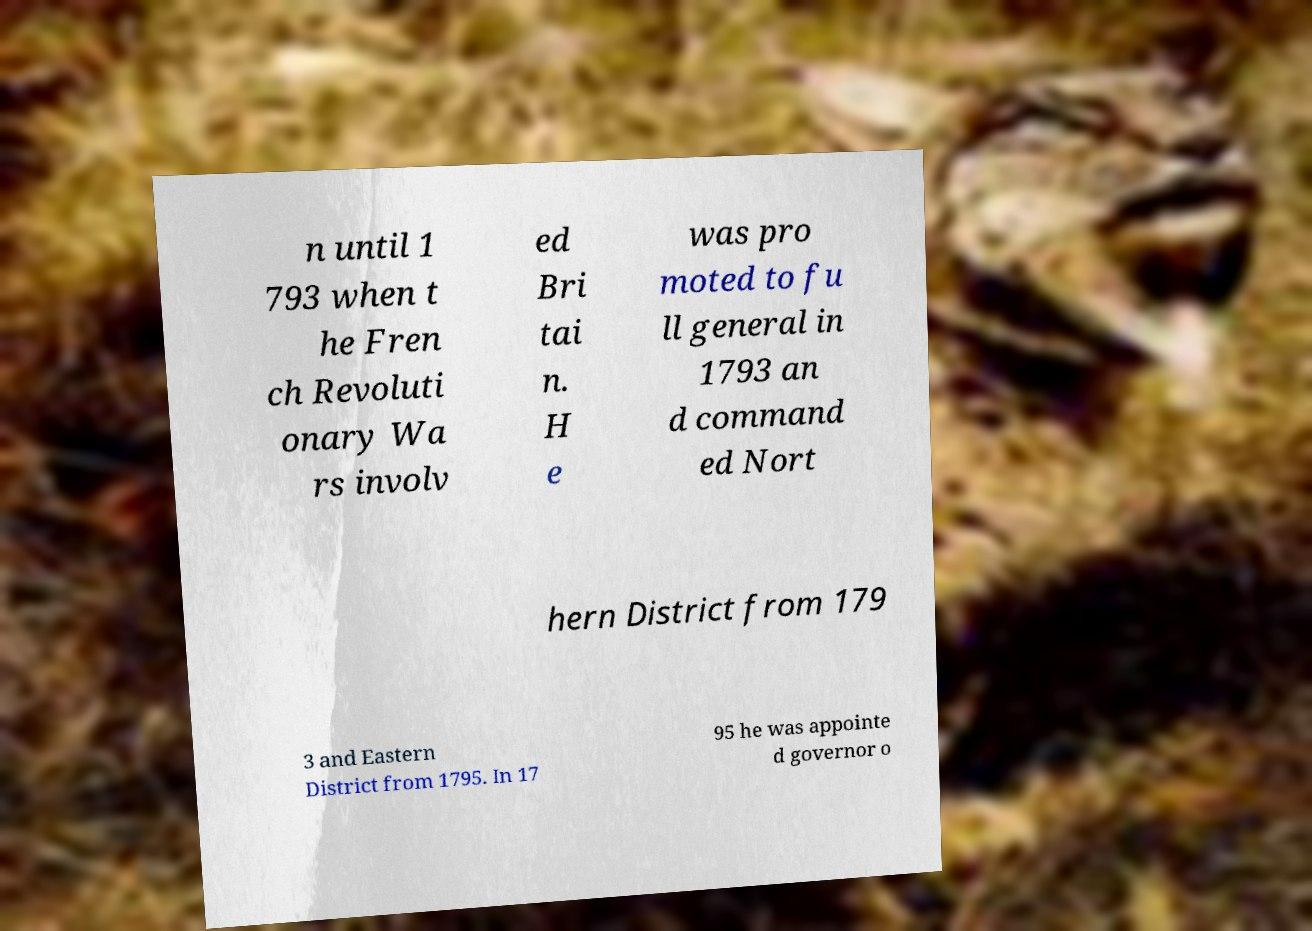Can you accurately transcribe the text from the provided image for me? n until 1 793 when t he Fren ch Revoluti onary Wa rs involv ed Bri tai n. H e was pro moted to fu ll general in 1793 an d command ed Nort hern District from 179 3 and Eastern District from 1795. In 17 95 he was appointe d governor o 